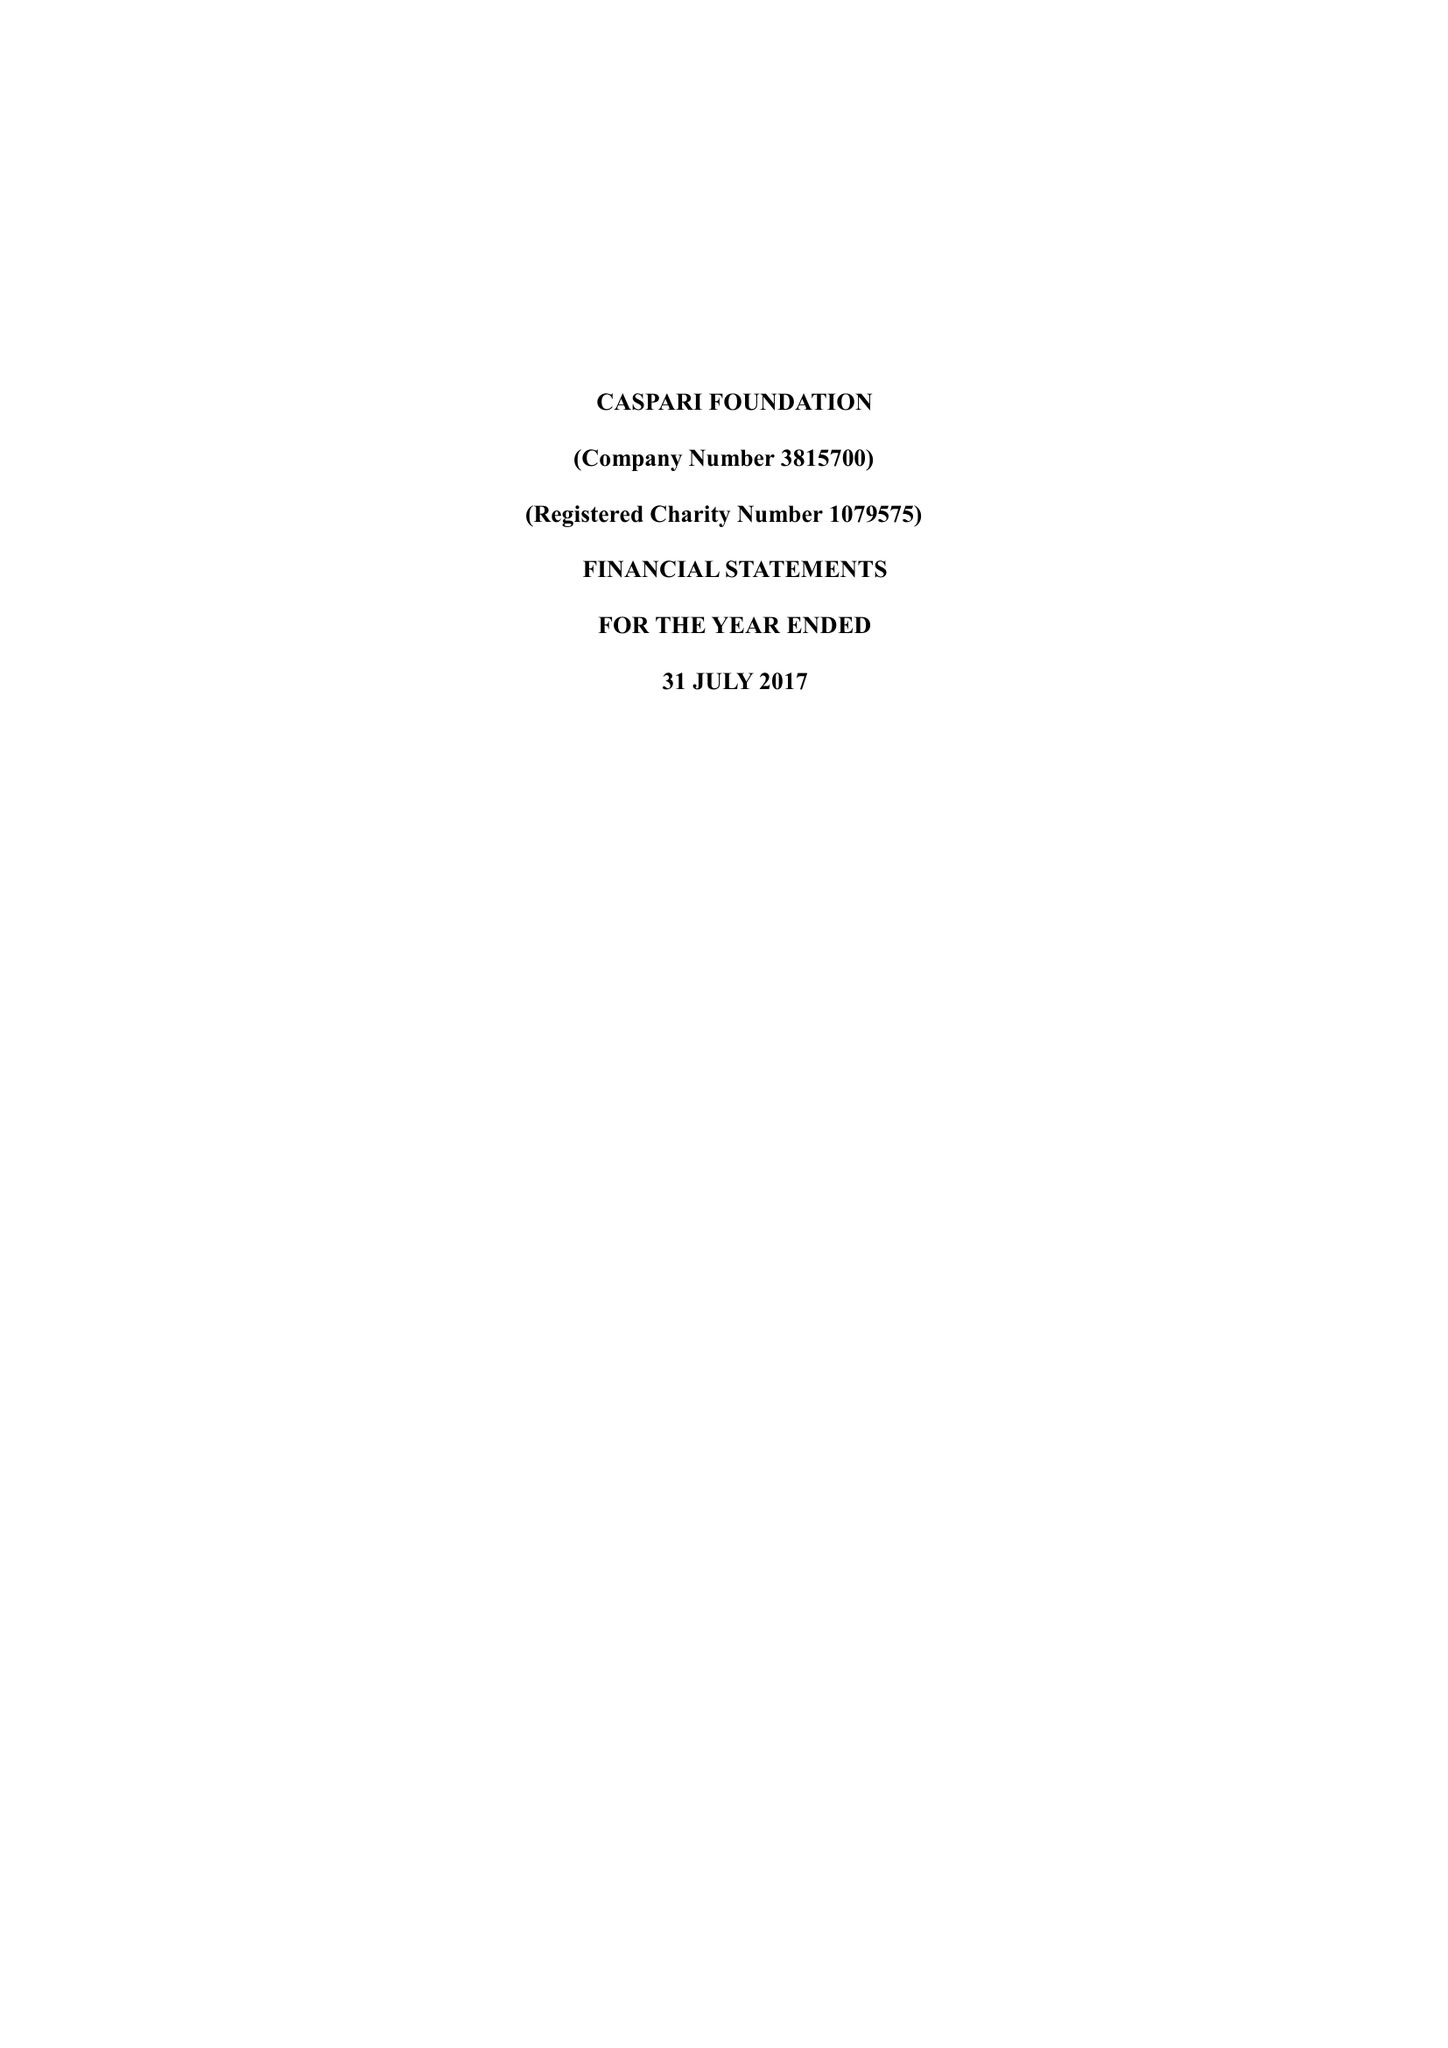What is the value for the charity_number?
Answer the question using a single word or phrase. 1079575 